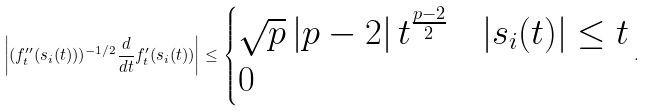Convert formula to latex. <formula><loc_0><loc_0><loc_500><loc_500>\left | ( f _ { t } ^ { \prime \prime } ( s _ { i } ( t ) ) ) ^ { - 1 / 2 } \frac { d } { d t } f _ { t } ^ { \prime } ( s _ { i } ( t ) ) \right | \leq \begin{cases} \sqrt { p } \left | p - 2 \right | t ^ { \frac { p - 2 } { 2 } } & | s _ { i } ( t ) | \leq t \\ 0 & \end{cases} .</formula> 